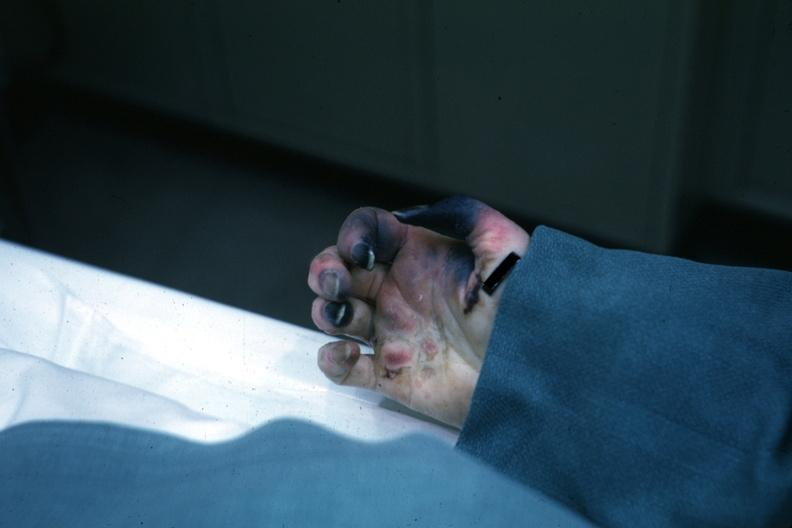what is present?
Answer the question using a single word or phrase. Gangrene fingers 